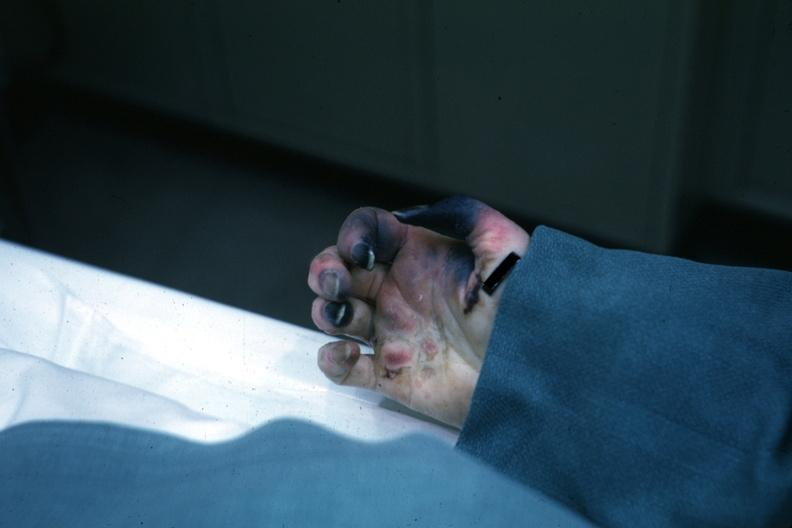what is present?
Answer the question using a single word or phrase. Gangrene fingers 